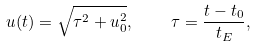Convert formula to latex. <formula><loc_0><loc_0><loc_500><loc_500>u ( t ) = \sqrt { \tau ^ { 2 } + u _ { 0 } ^ { 2 } } , \quad \tau = \frac { t - t _ { 0 } } { t _ { E } } ,</formula> 